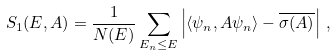<formula> <loc_0><loc_0><loc_500><loc_500>S _ { 1 } ( E , A ) = \frac { 1 } { N ( E ) } \sum _ { E _ { n } \leq E } \left | \langle \psi _ { n } , A \psi _ { n } \rangle - \overline { \sigma ( A ) } \right | \, ,</formula> 